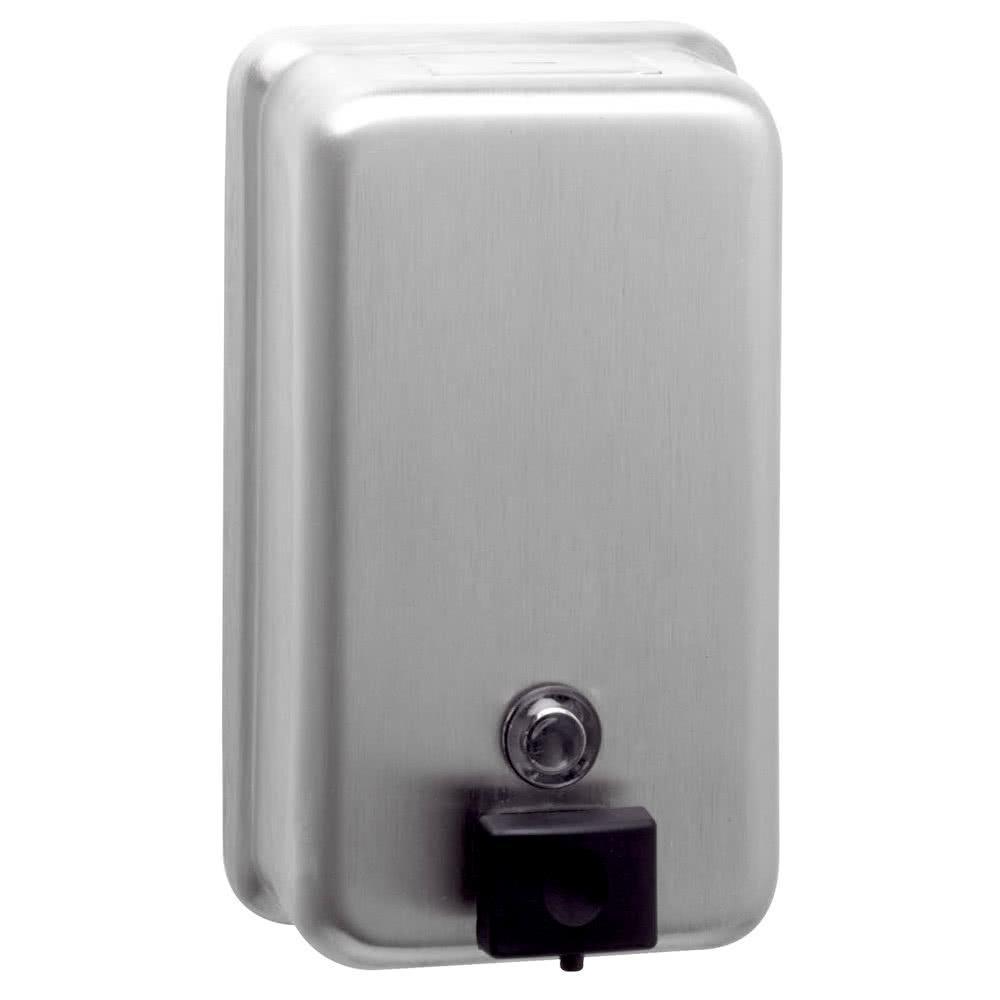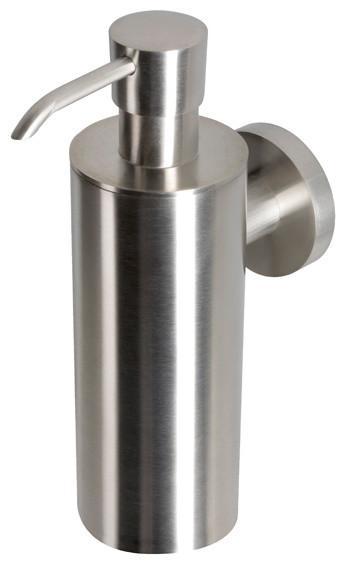The first image is the image on the left, the second image is the image on the right. Assess this claim about the two images: "The dispenser on the right image is tall and round.". Correct or not? Answer yes or no. Yes. The first image is the image on the left, the second image is the image on the right. For the images shown, is this caption "The dispenser on the right is a cylinder with a narrow nozzle." true? Answer yes or no. Yes. 